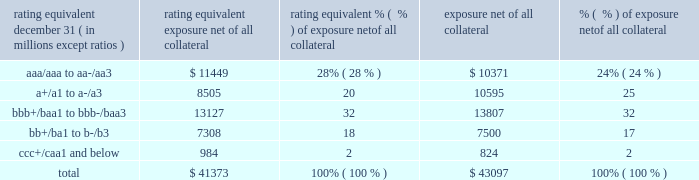Jpmorgan chase & co./2016 annual report 103 risk in the derivatives portfolio .
In addition , the firm 2019s risk management process takes into consideration the potential impact of wrong-way risk , which is broadly defined as the potential for increased correlation between the firm 2019s exposure to a counterparty ( avg ) and the counterparty 2019s credit quality .
Many factors may influence the nature and magnitude of these correlations over time .
To the extent that these correlations are identified , the firm may adjust the cva associated with that counterparty 2019s avg .
The firm risk manages exposure to changes in cva by entering into credit derivative transactions , as well as interest rate , foreign exchange , equity and commodity derivative transactions .
The accompanying graph shows exposure profiles to the firm 2019s current derivatives portfolio over the next 10 years as calculated by the peak , dre and avg metrics .
The three measures generally show that exposure will decline after the first year , if no new trades are added to the portfolio .
Exposure profile of derivatives measures december 31 , 2016 ( in billions ) the table summarizes the ratings profile by derivative counterparty of the firm 2019s derivative receivables , including credit derivatives , net of all collateral , at the dates indicated .
The ratings scale is based on the firm 2019s internal ratings , which generally correspond to the ratings as defined by s&p and moody 2019s .
Ratings profile of derivative receivables rating equivalent 2016 2015 ( a ) december 31 , ( in millions , except ratios ) exposure net of all collateral % (  % ) of exposure net of all collateral exposure net of all collateral % (  % ) of exposure net of all collateral .
( a ) prior period amounts have been revised to conform with the current period presentation .
As previously noted , the firm uses collateral agreements to mitigate counterparty credit risk .
The percentage of the firm 2019s derivatives transactions subject to collateral agreements 2014 excluding foreign exchange spot trades , which are not typically covered by collateral agreements due to their short maturity 2014 was 90% ( 90 % ) as of december 31 , 2016 , largely unchanged compared with 87% ( 87 % ) as of december 31 , 2015 .
Credit derivatives the firm uses credit derivatives for two primary purposes : first , in its capacity as a market-maker , and second , as an end-user to manage the firm 2019s own credit risk associated with various exposures .
For a detailed description of credit derivatives , see credit derivatives in note 6 .
Credit portfolio management activities included in the firm 2019s end-user activities are credit derivatives used to mitigate the credit risk associated with traditional lending activities ( loans and unfunded commitments ) and derivatives counterparty exposure in the firm 2019s wholesale businesses ( collectively , 201ccredit portfolio management 201d activities ) .
Information on credit portfolio management activities is provided in the table below .
For further information on derivatives used in credit portfolio management activities , see credit derivatives in note 6 .
The firm also uses credit derivatives as an end-user to manage other exposures , including credit risk arising from certain securities held in the firm 2019s market-making businesses .
These credit derivatives are not included in credit portfolio management activities ; for further information on these credit derivatives as well as credit derivatives used in the firm 2019s capacity as a market-maker in credit derivatives , see credit derivatives in note 6. .
What percentage of the 2015 ratings profile of derivative receivables had a rating equivalent for junk ratings? 
Computations: (17 + 2)
Answer: 19.0. 